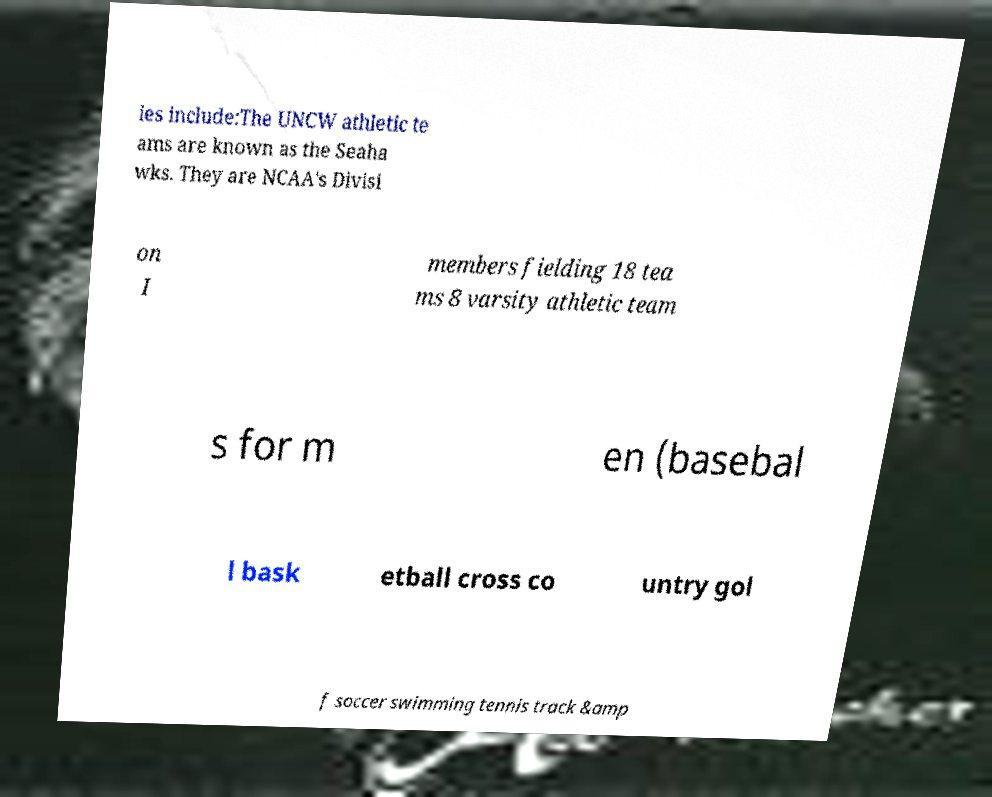Could you extract and type out the text from this image? ies include:The UNCW athletic te ams are known as the Seaha wks. They are NCAA's Divisi on I members fielding 18 tea ms 8 varsity athletic team s for m en (basebal l bask etball cross co untry gol f soccer swimming tennis track &amp 